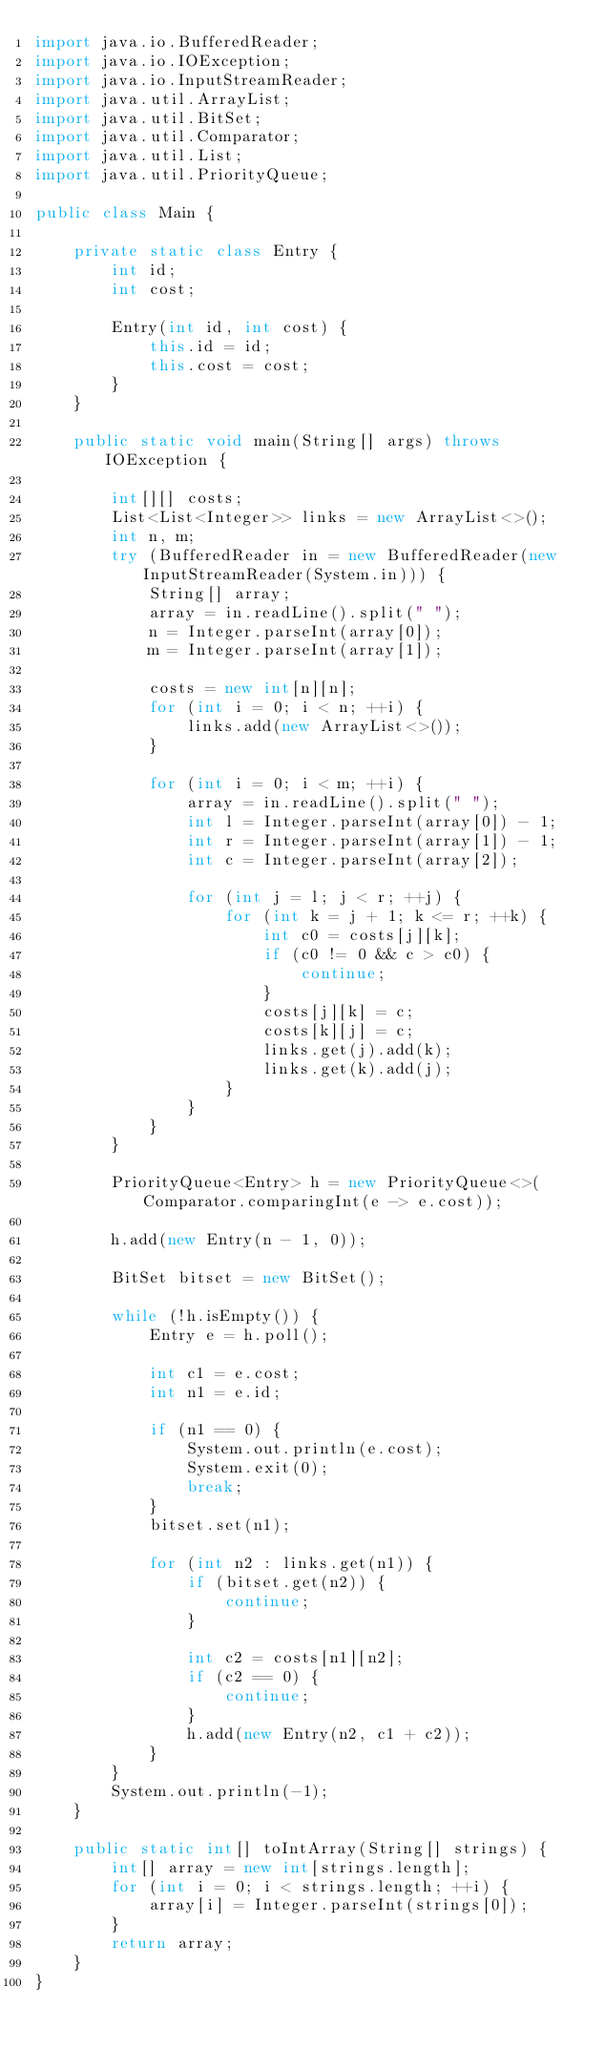<code> <loc_0><loc_0><loc_500><loc_500><_Java_>import java.io.BufferedReader;
import java.io.IOException;
import java.io.InputStreamReader;
import java.util.ArrayList;
import java.util.BitSet;
import java.util.Comparator;
import java.util.List;
import java.util.PriorityQueue;

public class Main {

    private static class Entry {
        int id;
        int cost;
        
        Entry(int id, int cost) {
            this.id = id;
            this.cost = cost;
        }
    }

    public static void main(String[] args) throws IOException {

        int[][] costs;
        List<List<Integer>> links = new ArrayList<>();
        int n, m;
        try (BufferedReader in = new BufferedReader(new InputStreamReader(System.in))) {
            String[] array;
            array = in.readLine().split(" ");
            n = Integer.parseInt(array[0]);
            m = Integer.parseInt(array[1]);
            
            costs = new int[n][n];
            for (int i = 0; i < n; ++i) {
                links.add(new ArrayList<>());
            }
            
            for (int i = 0; i < m; ++i) {
                array = in.readLine().split(" ");
                int l = Integer.parseInt(array[0]) - 1;
                int r = Integer.parseInt(array[1]) - 1;
                int c = Integer.parseInt(array[2]);

                for (int j = l; j < r; ++j) {
                    for (int k = j + 1; k <= r; ++k) {
                        int c0 = costs[j][k];
                        if (c0 != 0 && c > c0) {
                            continue;
                        }
                        costs[j][k] = c;
                        costs[k][j] = c;
                        links.get(j).add(k);
                        links.get(k).add(j);
                    }
                }
            }
        }
        
        PriorityQueue<Entry> h = new PriorityQueue<>(Comparator.comparingInt(e -> e.cost));
        
        h.add(new Entry(n - 1, 0));
        
        BitSet bitset = new BitSet();
        
        while (!h.isEmpty()) {
            Entry e = h.poll();
            
            int c1 = e.cost;
            int n1 = e.id;
            
            if (n1 == 0) {
                System.out.println(e.cost);
                System.exit(0);
                break;
            }
            bitset.set(n1);
            
            for (int n2 : links.get(n1)) {
                if (bitset.get(n2)) {
                    continue;
                }
                
                int c2 = costs[n1][n2];
                if (c2 == 0) {
                    continue;
                }
                h.add(new Entry(n2, c1 + c2));
            }
        }
        System.out.println(-1);
    }
    
    public static int[] toIntArray(String[] strings) {
        int[] array = new int[strings.length];
        for (int i = 0; i < strings.length; ++i) {
            array[i] = Integer.parseInt(strings[0]);
        }
        return array;
    }
}
</code> 